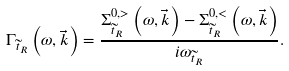<formula> <loc_0><loc_0><loc_500><loc_500>\Gamma _ { \widetilde { t } _ { R } } \left ( \omega , \vec { k } \right ) = \frac { \Sigma ^ { 0 , > } _ { \widetilde { t } _ { R } } \left ( \omega , \vec { k } \right ) - \Sigma ^ { 0 , < } _ { \widetilde { t } _ { R } } \left ( \omega , \vec { k } \right ) } { i \omega _ { \widetilde { t } _ { R } } } .</formula> 